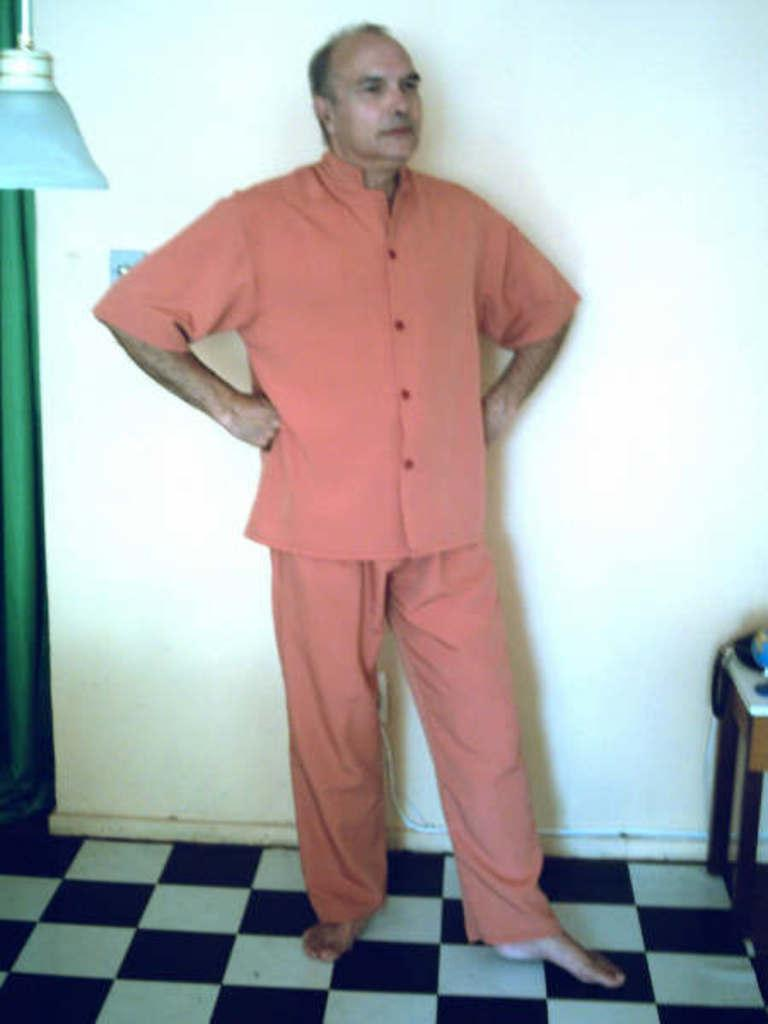What is the main subject of the image? There is a person standing in the image. What can be seen in the background of the image? There is a wall in the background of the image. What color is the cloth on the left side of the image? There is a green color cloth on the left side of the image. What is located on the left side of the image besides the cloth? There is a light on the left side of the image. How many swings are visible in the image? There are no swings present in the image. What type of wrench is being used by the person in the image? There is no wrench visible in the image, and the person's actions are not described. 